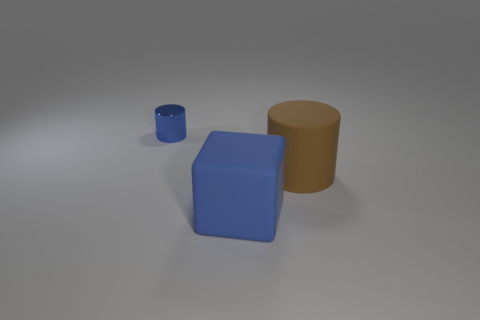Are there any other things that are the same size as the metal cylinder?
Your response must be concise. No. What shape is the other object that is the same color as the metallic thing?
Keep it short and to the point. Cube. There is a cylinder left of the big cube; is its color the same as the big thing left of the large brown cylinder?
Keep it short and to the point. Yes. Is there anything else of the same color as the small cylinder?
Provide a succinct answer. Yes. Are there fewer tiny blue cylinders that are in front of the big blue block than blue metallic cylinders?
Your answer should be very brief. Yes. There is a large matte thing behind the blue thing to the right of the cylinder that is behind the large brown matte object; what is its shape?
Offer a terse response. Cylinder. Is the blue rubber object the same shape as the tiny object?
Provide a succinct answer. No. How many other objects are there of the same shape as the big blue rubber thing?
Provide a succinct answer. 0. What is the color of the rubber cylinder that is the same size as the matte block?
Offer a terse response. Brown. Are there the same number of big blue blocks that are behind the blue cube and tiny metal cylinders?
Your answer should be very brief. No. 